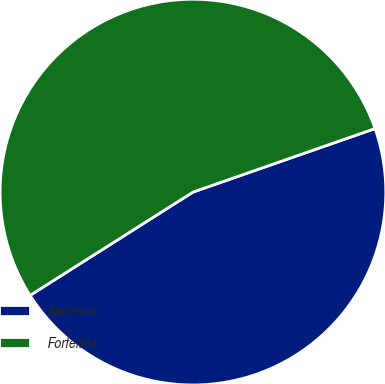Convert chart. <chart><loc_0><loc_0><loc_500><loc_500><pie_chart><fcel>Awarded<fcel>Forfeited<nl><fcel>46.35%<fcel>53.65%<nl></chart> 